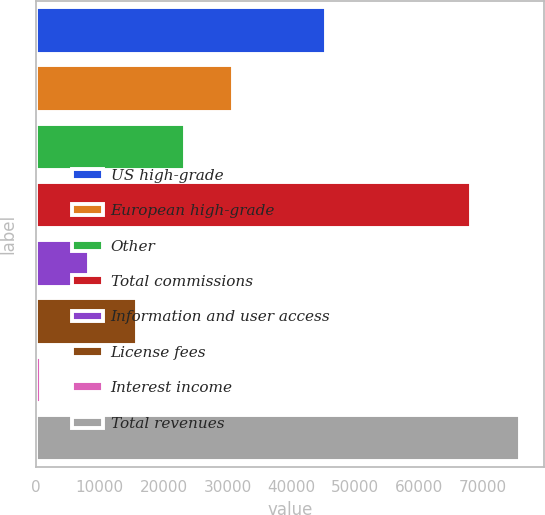Convert chart. <chart><loc_0><loc_0><loc_500><loc_500><bar_chart><fcel>US high-grade<fcel>European high-grade<fcel>Other<fcel>Total commissions<fcel>Information and user access<fcel>License fees<fcel>Interest income<fcel>Total revenues<nl><fcel>45465<fcel>30848<fcel>23356.5<fcel>68172<fcel>8373.5<fcel>15865<fcel>882<fcel>75797<nl></chart> 